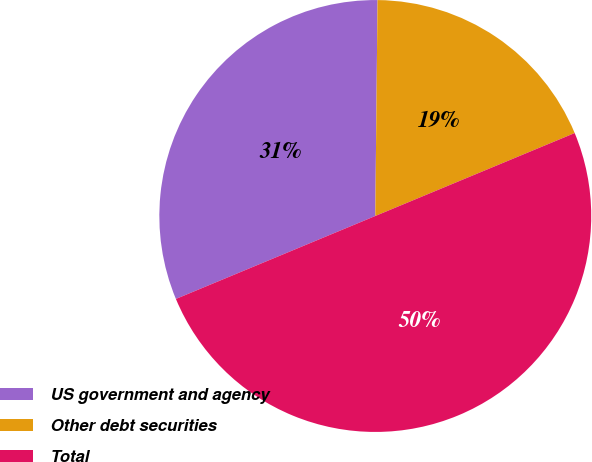Convert chart. <chart><loc_0><loc_0><loc_500><loc_500><pie_chart><fcel>US government and agency<fcel>Other debt securities<fcel>Total<nl><fcel>31.44%<fcel>18.56%<fcel>50.0%<nl></chart> 